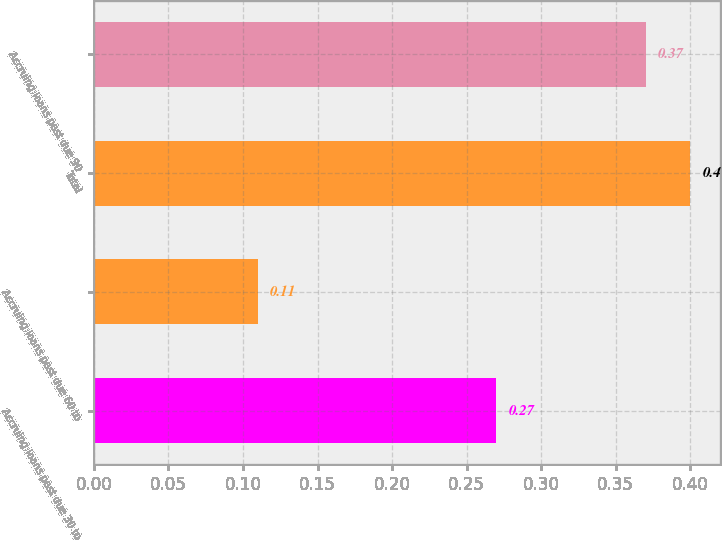<chart> <loc_0><loc_0><loc_500><loc_500><bar_chart><fcel>Accruing loans past due 30 to<fcel>Accruing loans past due 60 to<fcel>Total<fcel>Accruing loans past due 90<nl><fcel>0.27<fcel>0.11<fcel>0.4<fcel>0.37<nl></chart> 